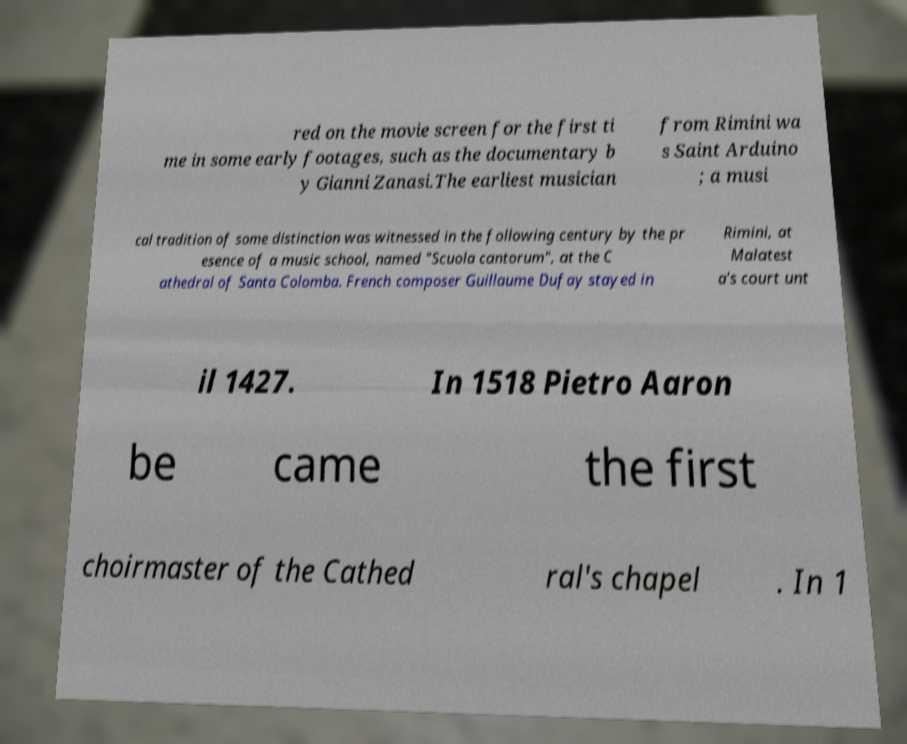Please read and relay the text visible in this image. What does it say? red on the movie screen for the first ti me in some early footages, such as the documentary b y Gianni Zanasi.The earliest musician from Rimini wa s Saint Arduino ; a musi cal tradition of some distinction was witnessed in the following century by the pr esence of a music school, named "Scuola cantorum", at the C athedral of Santa Colomba. French composer Guillaume Dufay stayed in Rimini, at Malatest a's court unt il 1427. In 1518 Pietro Aaron be came the first choirmaster of the Cathed ral's chapel . In 1 